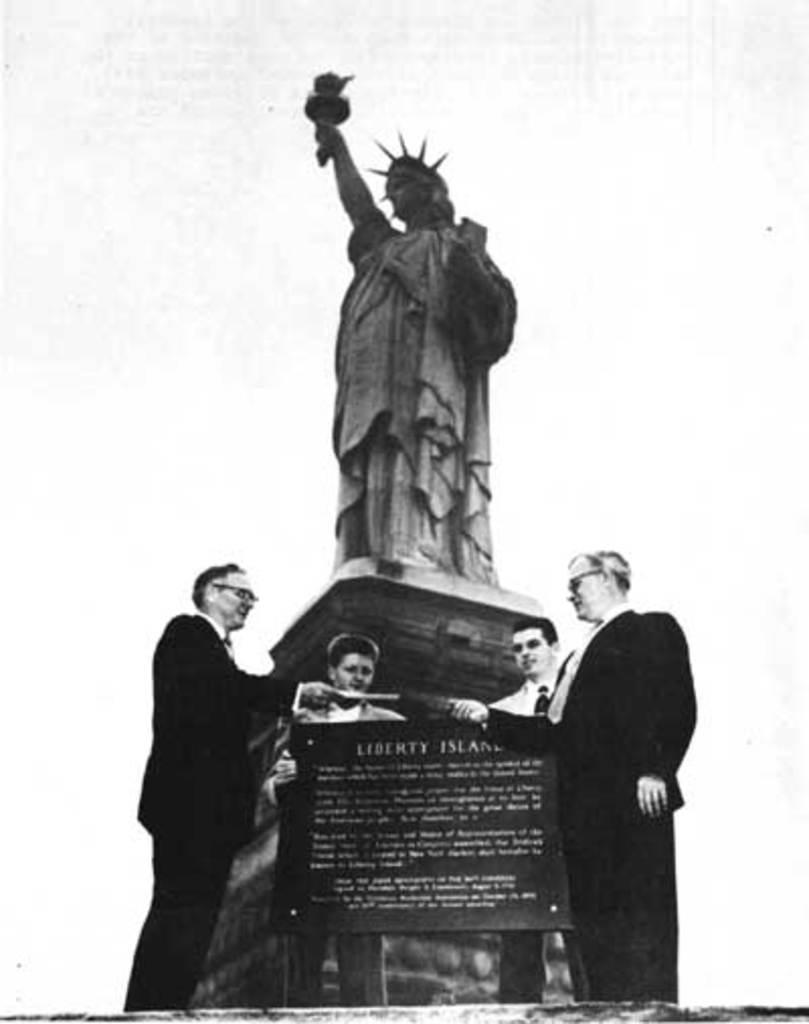What is happening in the center of the image? There are people standing in the center of the image. What famous landmark can be seen in the image? The Liberty Statue is visible in the image. What additional object is present in the image? There is a banner in the image. Where is the flame located in the image? There is no flame present in the image. What type of basin is visible in the image? There is no basin present in the image. 